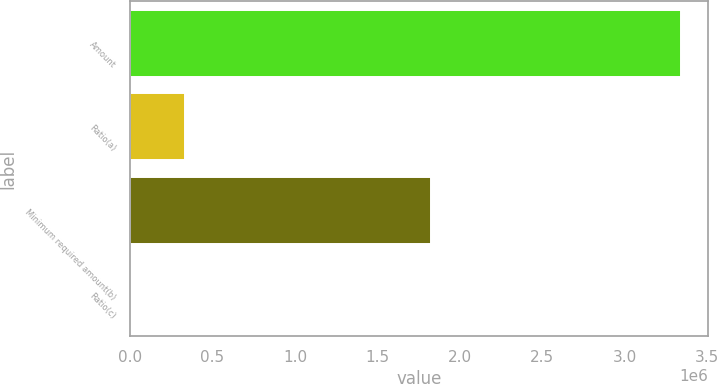Convert chart. <chart><loc_0><loc_0><loc_500><loc_500><bar_chart><fcel>Amount<fcel>Ratio(a)<fcel>Minimum required amount(b)<fcel>Ratio(c)<nl><fcel>3.34097e+06<fcel>334103<fcel>1.82736e+06<fcel>6.73<nl></chart> 